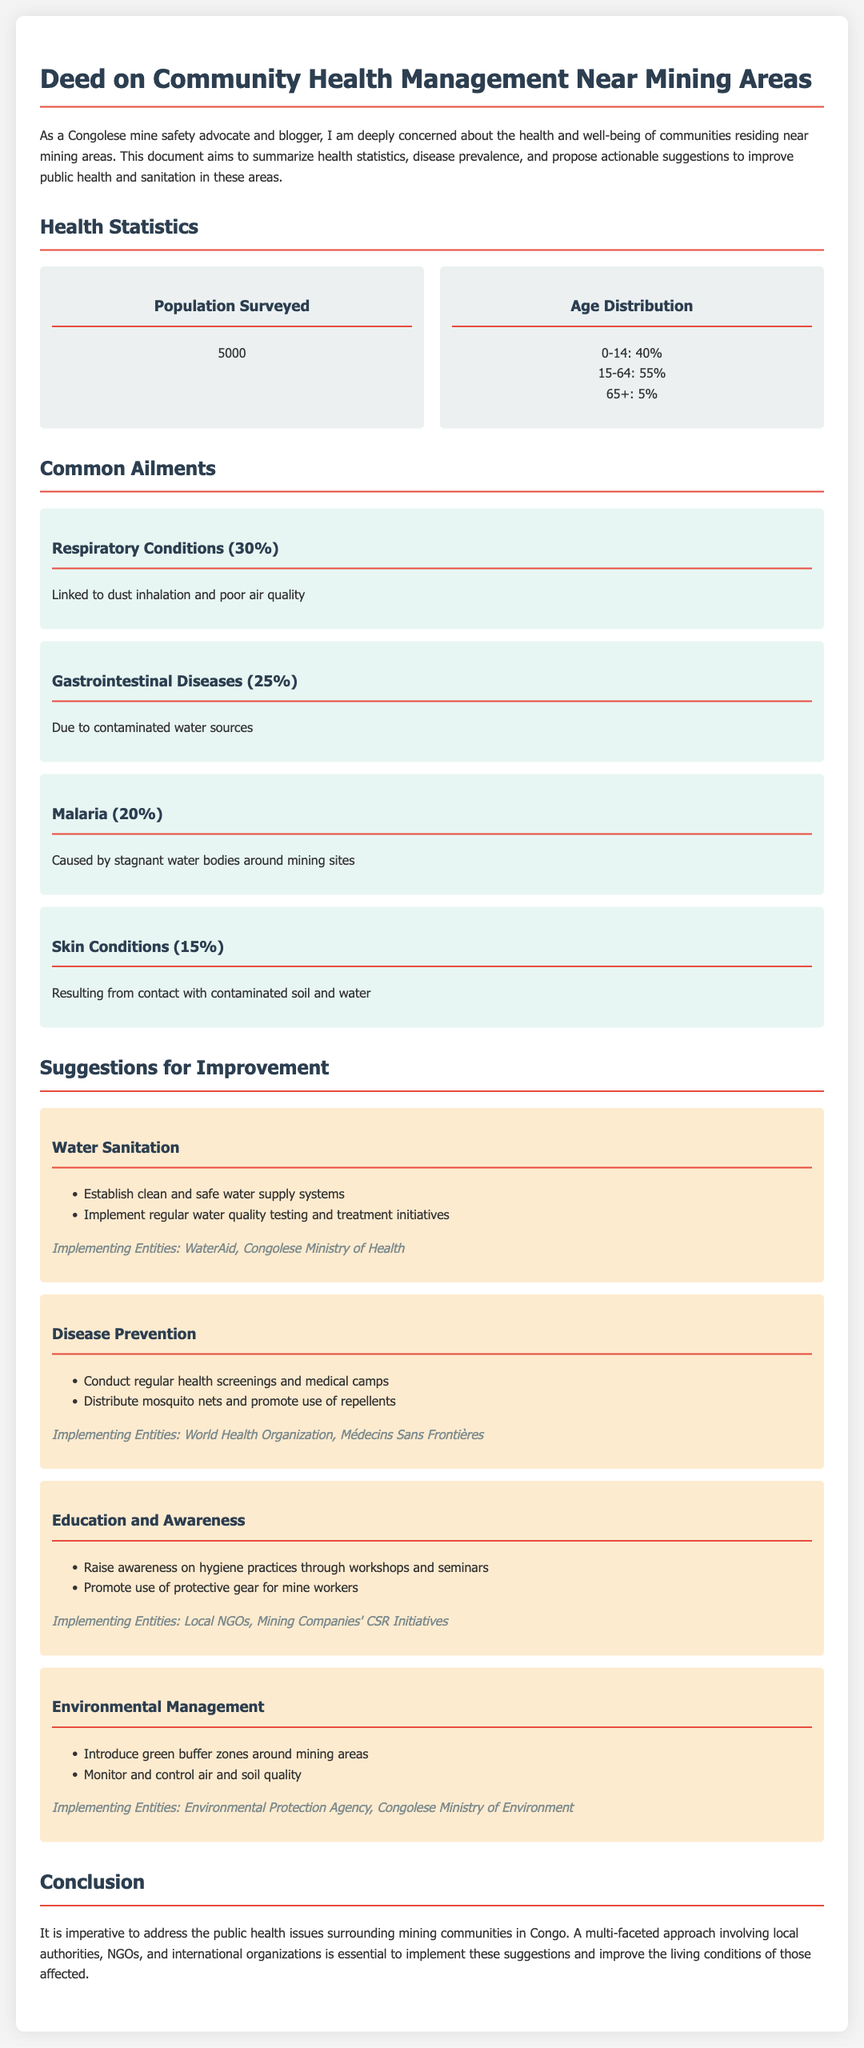What is the population surveyed? The population surveyed is a specific numerical value mentioned in the document under health statistics.
Answer: 5000 What percentage of the surveyed population are aged 0-14? This percentage is detailed in the age distribution section of the health statistics.
Answer: 40% What is the prevalence of respiratory conditions in the community? The document states the prevalence percentage for respiratory conditions as part of common ailments.
Answer: 30% Which organization is responsible for disease prevention suggestions? The implementing entities for disease prevention are listed in the suggestions section of the document.
Answer: World Health Organization What health issue is linked to contaminated water sources? This health issue is mentioned in the common ailments section relating to gastrointestinal diseases.
Answer: Gastrointestinal Diseases What suggestion is made for improving water sanitation? The document provides specific actions under the suggestion for water sanitation.
Answer: Establish clean and safe water supply systems What is the main cause of malaria according to the document? The document describes the root cause of malaria in the context of common ailments in mining areas.
Answer: Stagnant water bodies How many implementing entities are listed under environmental management? The document specifies the number of distinct organizations mentioned for environmental management suggestions.
Answer: 2 